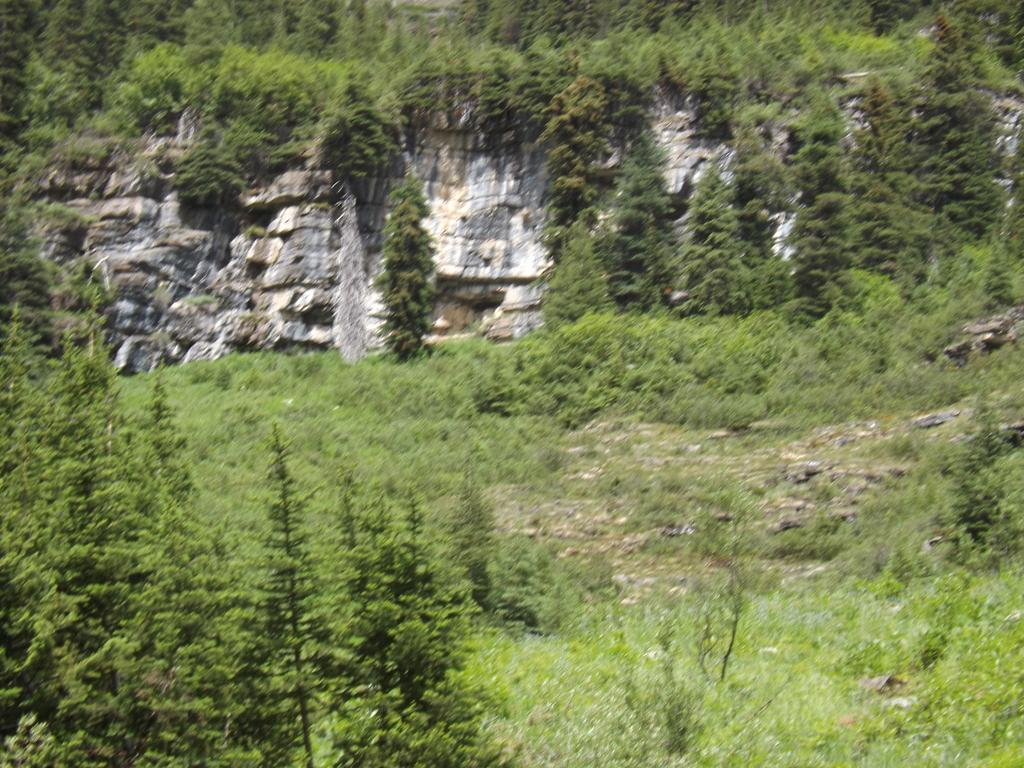What type of landscape feature is present in the image? There is a hill in the image. What type of vegetation can be seen in the image? There are trees and plants in the image. Where is the governor's nest located in the image? There is no governor or nest present in the image. What type of cabbage can be seen growing on the hill in the image? There is no cabbage visible in the image; only trees and plants are present. 